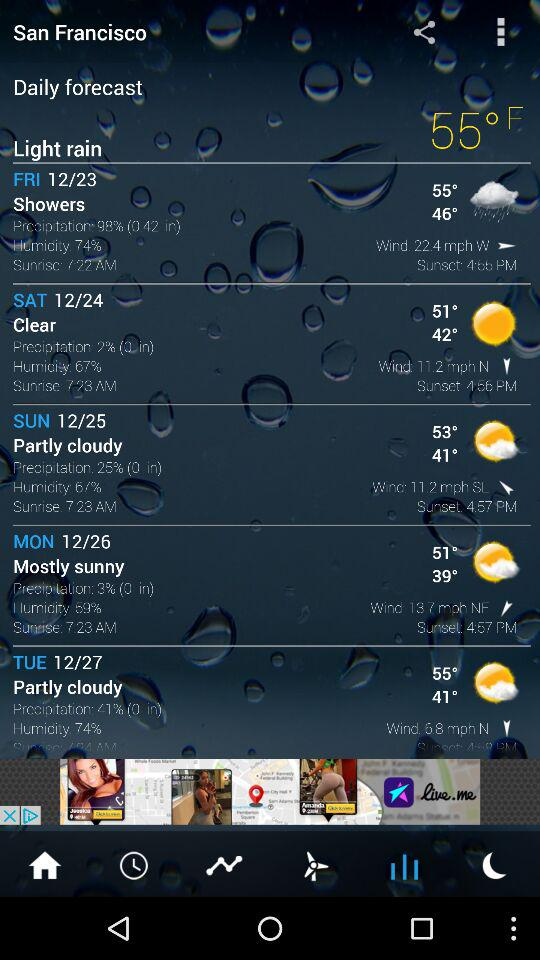What is the sunset time on Tuesday? The sunset time on Tuesday is 4.58 PM. 